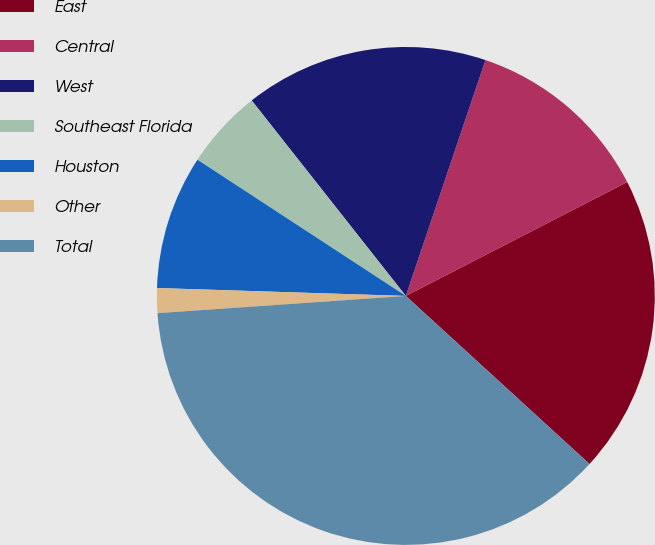<chart> <loc_0><loc_0><loc_500><loc_500><pie_chart><fcel>East<fcel>Central<fcel>West<fcel>Southeast Florida<fcel>Houston<fcel>Other<fcel>Total<nl><fcel>19.36%<fcel>12.26%<fcel>15.81%<fcel>5.16%<fcel>8.71%<fcel>1.61%<fcel>37.11%<nl></chart> 